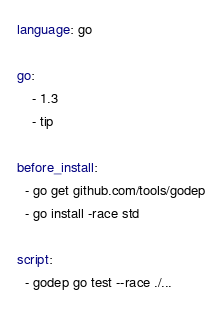Convert code to text. <code><loc_0><loc_0><loc_500><loc_500><_YAML_>language: go

go:
    - 1.3
    - tip

before_install:
  - go get github.com/tools/godep
  - go install -race std

script: 
  - godep go test --race ./...

</code> 